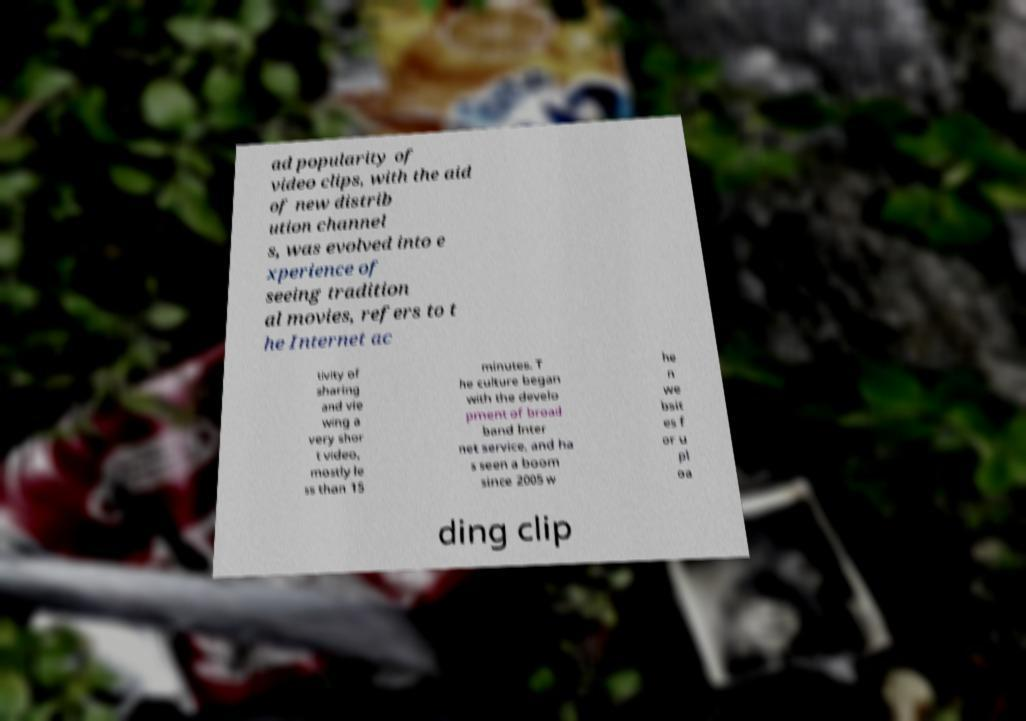Please read and relay the text visible in this image. What does it say? ad popularity of video clips, with the aid of new distrib ution channel s, was evolved into e xperience of seeing tradition al movies, refers to t he Internet ac tivity of sharing and vie wing a very shor t video, mostly le ss than 15 minutes. T he culture began with the develo pment of broad band Inter net service, and ha s seen a boom since 2005 w he n we bsit es f or u pl oa ding clip 